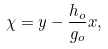<formula> <loc_0><loc_0><loc_500><loc_500>\chi = y - \frac { h _ { o } } { g _ { o } } x ,</formula> 